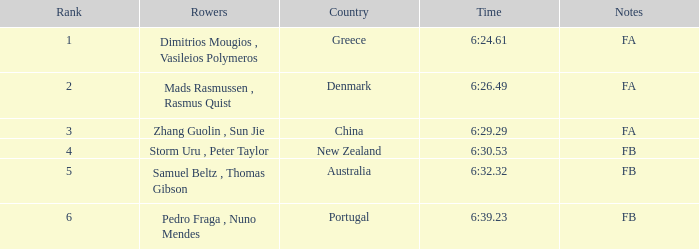What nation has a ranking below 6, a timing of 6:3 Australia. 